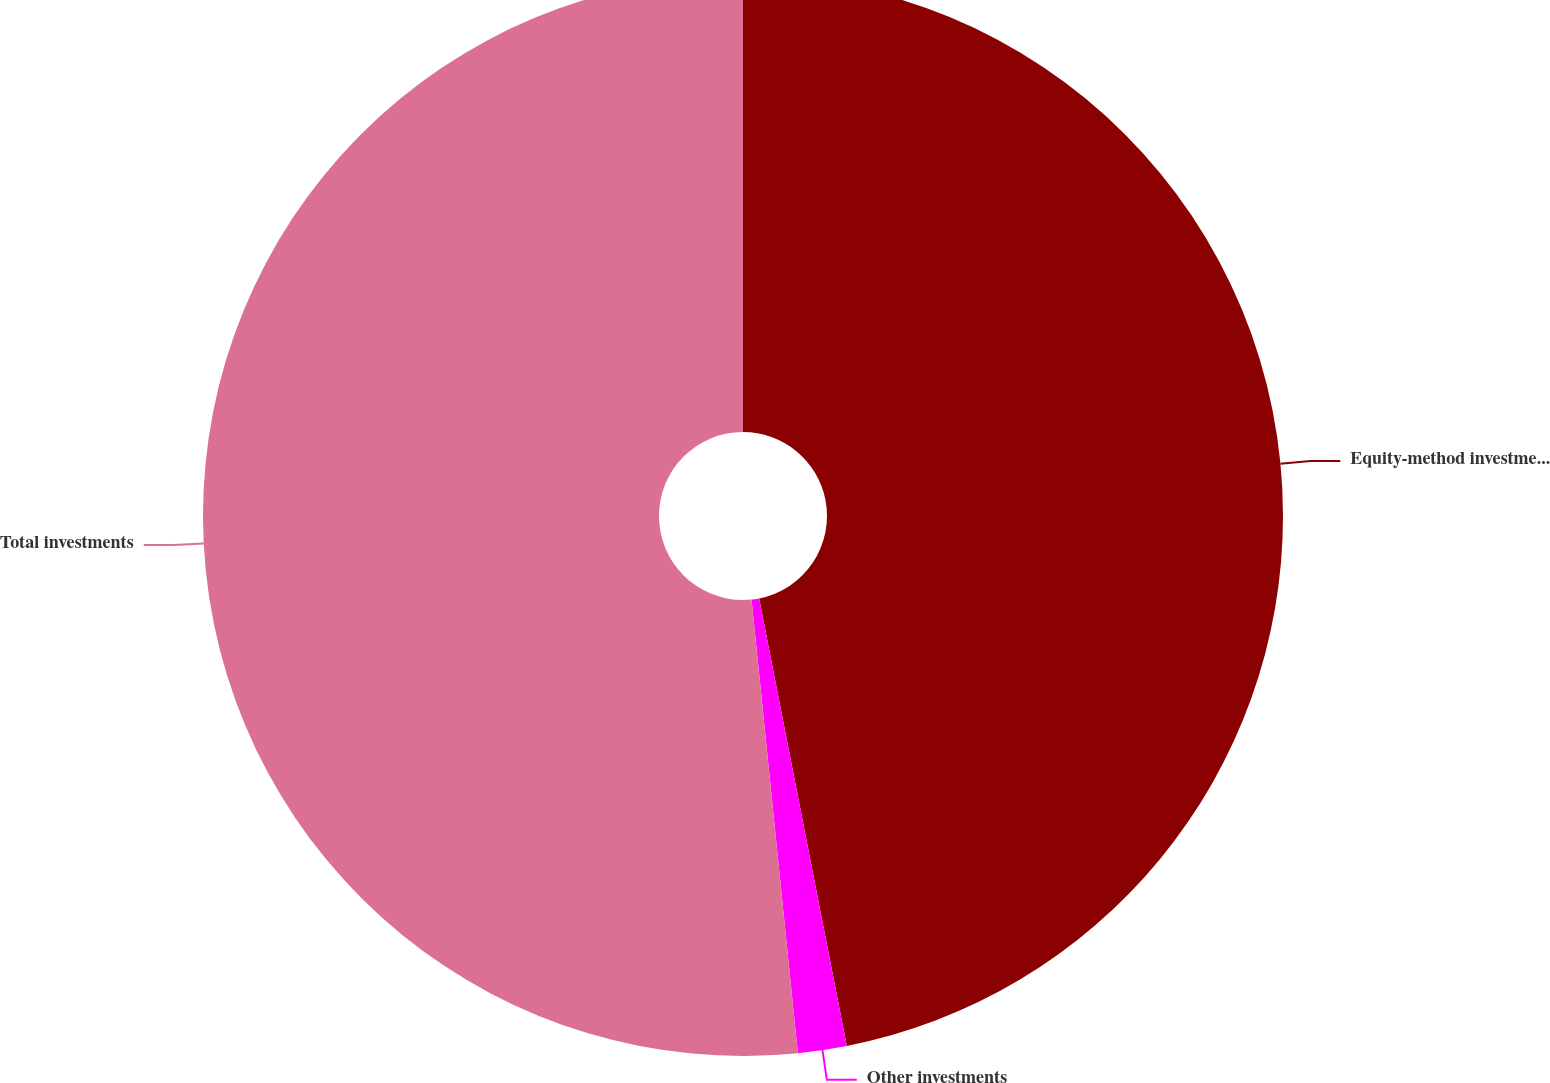<chart> <loc_0><loc_0><loc_500><loc_500><pie_chart><fcel>Equity-method investments<fcel>Other investments<fcel>Total investments<nl><fcel>46.92%<fcel>1.46%<fcel>51.62%<nl></chart> 